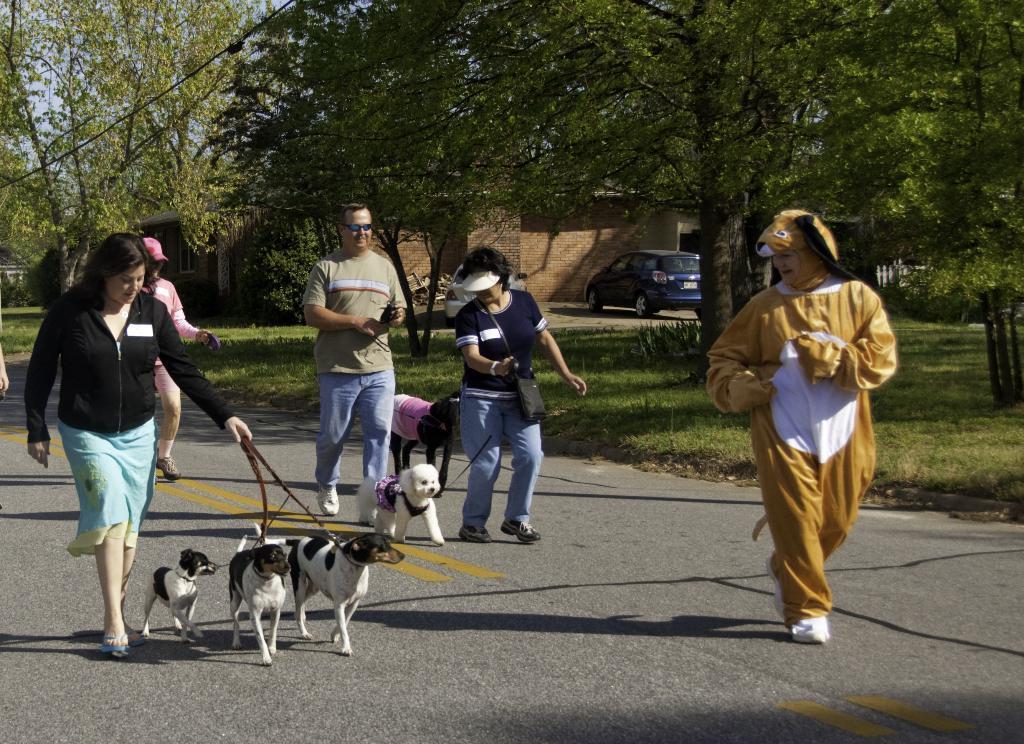Describe this image in one or two sentences. In this image there are few people who are running on the road along with there dogs. On the right side there is a person running on the road by wearing the costume. In the background there are trees and a house. In front of the house there is a car. 